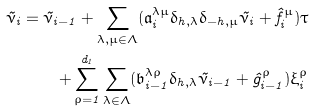<formula> <loc_0><loc_0><loc_500><loc_500>\tilde { \nu } _ { i } = \tilde { \nu } _ { i - 1 } + \sum _ { \lambda , \mu \in \Lambda } ( \mathfrak { a } ^ { \lambda \mu } _ { i } \delta _ { h , \lambda } \delta _ { - h , \mu } \tilde { \nu } _ { i } + \hat { f } ^ { \mu } _ { i } ) \tau \\ + \sum _ { \rho = 1 } ^ { d _ { 1 } } \sum _ { \lambda \in \Lambda } ( \mathfrak { b } ^ { \lambda \rho } _ { i - 1 } \delta _ { h , \lambda } \tilde { \nu } _ { i - 1 } + \hat { g } ^ { \rho } _ { i - 1 } ) \xi ^ { \rho } _ { i }</formula> 